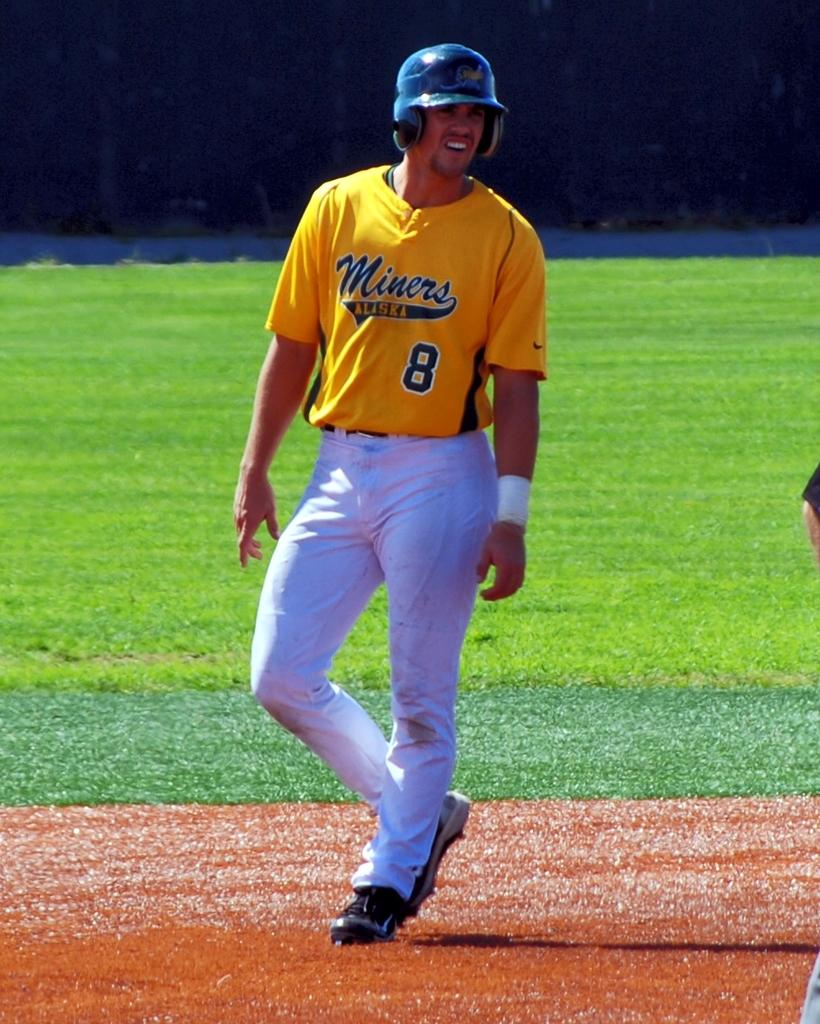<image>
Render a clear and concise summary of the photo. A baseball player wearing a yellow shirt with the words Miners Alaska 8 written on it. 